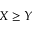<formula> <loc_0><loc_0><loc_500><loc_500>X \geq Y</formula> 